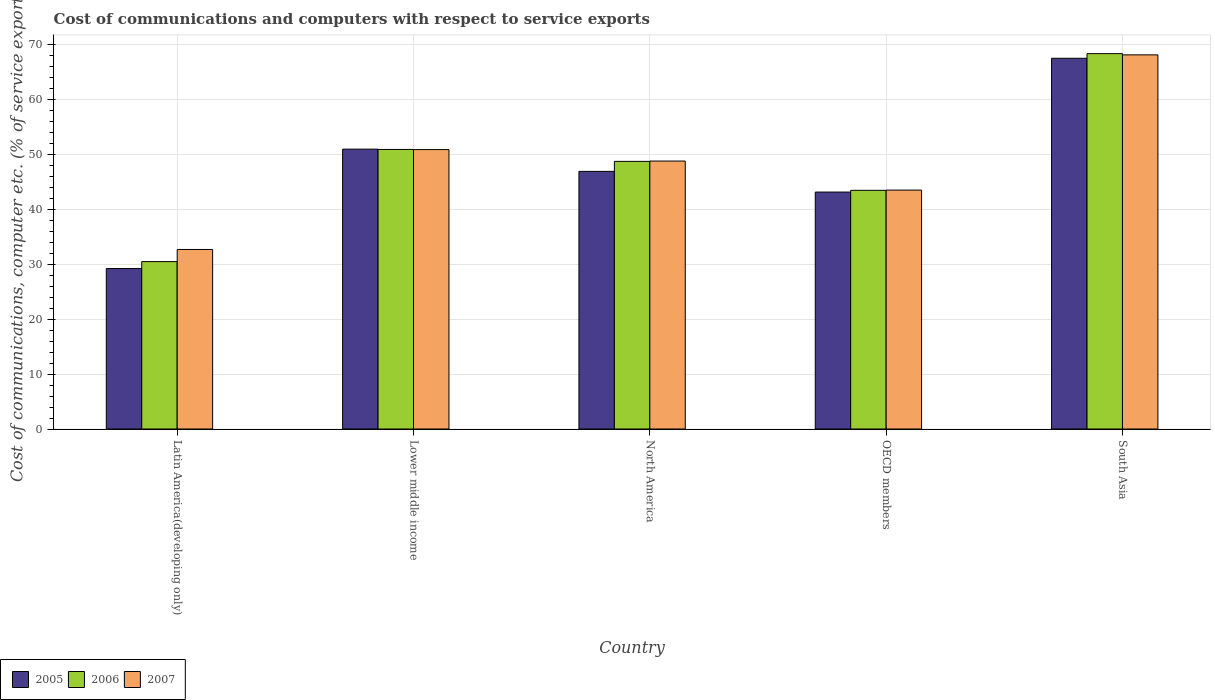How many different coloured bars are there?
Provide a short and direct response. 3. Are the number of bars per tick equal to the number of legend labels?
Provide a succinct answer. Yes. Are the number of bars on each tick of the X-axis equal?
Keep it short and to the point. Yes. How many bars are there on the 4th tick from the right?
Your answer should be compact. 3. What is the cost of communications and computers in 2007 in Latin America(developing only)?
Your answer should be very brief. 32.71. Across all countries, what is the maximum cost of communications and computers in 2007?
Offer a terse response. 68.16. Across all countries, what is the minimum cost of communications and computers in 2007?
Your response must be concise. 32.71. In which country was the cost of communications and computers in 2007 maximum?
Your response must be concise. South Asia. In which country was the cost of communications and computers in 2006 minimum?
Your answer should be compact. Latin America(developing only). What is the total cost of communications and computers in 2005 in the graph?
Give a very brief answer. 237.86. What is the difference between the cost of communications and computers in 2006 in North America and that in South Asia?
Provide a succinct answer. -19.63. What is the difference between the cost of communications and computers in 2005 in Latin America(developing only) and the cost of communications and computers in 2006 in Lower middle income?
Your response must be concise. -21.7. What is the average cost of communications and computers in 2005 per country?
Ensure brevity in your answer.  47.57. What is the difference between the cost of communications and computers of/in 2005 and cost of communications and computers of/in 2006 in OECD members?
Provide a succinct answer. -0.31. What is the ratio of the cost of communications and computers in 2005 in Latin America(developing only) to that in South Asia?
Provide a succinct answer. 0.43. What is the difference between the highest and the second highest cost of communications and computers in 2007?
Keep it short and to the point. -2.09. What is the difference between the highest and the lowest cost of communications and computers in 2005?
Provide a succinct answer. 38.31. Is the sum of the cost of communications and computers in 2007 in Latin America(developing only) and South Asia greater than the maximum cost of communications and computers in 2006 across all countries?
Your answer should be compact. Yes. What does the 3rd bar from the left in South Asia represents?
Your answer should be compact. 2007. Are all the bars in the graph horizontal?
Your answer should be compact. No. How many countries are there in the graph?
Provide a succinct answer. 5. Are the values on the major ticks of Y-axis written in scientific E-notation?
Offer a very short reply. No. What is the title of the graph?
Ensure brevity in your answer.  Cost of communications and computers with respect to service exports. What is the label or title of the Y-axis?
Your answer should be very brief. Cost of communications, computer etc. (% of service exports). What is the Cost of communications, computer etc. (% of service exports) in 2005 in Latin America(developing only)?
Your response must be concise. 29.23. What is the Cost of communications, computer etc. (% of service exports) in 2006 in Latin America(developing only)?
Keep it short and to the point. 30.5. What is the Cost of communications, computer etc. (% of service exports) of 2007 in Latin America(developing only)?
Provide a short and direct response. 32.71. What is the Cost of communications, computer etc. (% of service exports) of 2005 in Lower middle income?
Offer a terse response. 50.99. What is the Cost of communications, computer etc. (% of service exports) in 2006 in Lower middle income?
Provide a short and direct response. 50.93. What is the Cost of communications, computer etc. (% of service exports) in 2007 in Lower middle income?
Provide a succinct answer. 50.91. What is the Cost of communications, computer etc. (% of service exports) of 2005 in North America?
Your response must be concise. 46.93. What is the Cost of communications, computer etc. (% of service exports) of 2006 in North America?
Ensure brevity in your answer.  48.76. What is the Cost of communications, computer etc. (% of service exports) of 2007 in North America?
Ensure brevity in your answer.  48.82. What is the Cost of communications, computer etc. (% of service exports) in 2005 in OECD members?
Give a very brief answer. 43.17. What is the Cost of communications, computer etc. (% of service exports) of 2006 in OECD members?
Your response must be concise. 43.48. What is the Cost of communications, computer etc. (% of service exports) of 2007 in OECD members?
Offer a very short reply. 43.53. What is the Cost of communications, computer etc. (% of service exports) of 2005 in South Asia?
Your answer should be very brief. 67.54. What is the Cost of communications, computer etc. (% of service exports) of 2006 in South Asia?
Your answer should be compact. 68.39. What is the Cost of communications, computer etc. (% of service exports) in 2007 in South Asia?
Offer a terse response. 68.16. Across all countries, what is the maximum Cost of communications, computer etc. (% of service exports) of 2005?
Provide a succinct answer. 67.54. Across all countries, what is the maximum Cost of communications, computer etc. (% of service exports) of 2006?
Your response must be concise. 68.39. Across all countries, what is the maximum Cost of communications, computer etc. (% of service exports) in 2007?
Your answer should be very brief. 68.16. Across all countries, what is the minimum Cost of communications, computer etc. (% of service exports) in 2005?
Your answer should be compact. 29.23. Across all countries, what is the minimum Cost of communications, computer etc. (% of service exports) in 2006?
Offer a very short reply. 30.5. Across all countries, what is the minimum Cost of communications, computer etc. (% of service exports) of 2007?
Make the answer very short. 32.71. What is the total Cost of communications, computer etc. (% of service exports) in 2005 in the graph?
Provide a short and direct response. 237.86. What is the total Cost of communications, computer etc. (% of service exports) of 2006 in the graph?
Your response must be concise. 242.05. What is the total Cost of communications, computer etc. (% of service exports) in 2007 in the graph?
Keep it short and to the point. 244.12. What is the difference between the Cost of communications, computer etc. (% of service exports) in 2005 in Latin America(developing only) and that in Lower middle income?
Your answer should be very brief. -21.75. What is the difference between the Cost of communications, computer etc. (% of service exports) in 2006 in Latin America(developing only) and that in Lower middle income?
Give a very brief answer. -20.43. What is the difference between the Cost of communications, computer etc. (% of service exports) in 2007 in Latin America(developing only) and that in Lower middle income?
Keep it short and to the point. -18.2. What is the difference between the Cost of communications, computer etc. (% of service exports) of 2005 in Latin America(developing only) and that in North America?
Your answer should be compact. -17.7. What is the difference between the Cost of communications, computer etc. (% of service exports) in 2006 in Latin America(developing only) and that in North America?
Provide a short and direct response. -18.26. What is the difference between the Cost of communications, computer etc. (% of service exports) in 2007 in Latin America(developing only) and that in North America?
Make the answer very short. -16.11. What is the difference between the Cost of communications, computer etc. (% of service exports) in 2005 in Latin America(developing only) and that in OECD members?
Keep it short and to the point. -13.93. What is the difference between the Cost of communications, computer etc. (% of service exports) of 2006 in Latin America(developing only) and that in OECD members?
Your response must be concise. -12.98. What is the difference between the Cost of communications, computer etc. (% of service exports) in 2007 in Latin America(developing only) and that in OECD members?
Your answer should be very brief. -10.82. What is the difference between the Cost of communications, computer etc. (% of service exports) of 2005 in Latin America(developing only) and that in South Asia?
Ensure brevity in your answer.  -38.31. What is the difference between the Cost of communications, computer etc. (% of service exports) in 2006 in Latin America(developing only) and that in South Asia?
Offer a very short reply. -37.89. What is the difference between the Cost of communications, computer etc. (% of service exports) of 2007 in Latin America(developing only) and that in South Asia?
Keep it short and to the point. -35.45. What is the difference between the Cost of communications, computer etc. (% of service exports) of 2005 in Lower middle income and that in North America?
Your answer should be compact. 4.05. What is the difference between the Cost of communications, computer etc. (% of service exports) in 2006 in Lower middle income and that in North America?
Offer a very short reply. 2.17. What is the difference between the Cost of communications, computer etc. (% of service exports) of 2007 in Lower middle income and that in North America?
Offer a terse response. 2.09. What is the difference between the Cost of communications, computer etc. (% of service exports) of 2005 in Lower middle income and that in OECD members?
Provide a short and direct response. 7.82. What is the difference between the Cost of communications, computer etc. (% of service exports) of 2006 in Lower middle income and that in OECD members?
Make the answer very short. 7.45. What is the difference between the Cost of communications, computer etc. (% of service exports) of 2007 in Lower middle income and that in OECD members?
Offer a very short reply. 7.38. What is the difference between the Cost of communications, computer etc. (% of service exports) of 2005 in Lower middle income and that in South Asia?
Give a very brief answer. -16.55. What is the difference between the Cost of communications, computer etc. (% of service exports) of 2006 in Lower middle income and that in South Asia?
Offer a terse response. -17.45. What is the difference between the Cost of communications, computer etc. (% of service exports) in 2007 in Lower middle income and that in South Asia?
Make the answer very short. -17.25. What is the difference between the Cost of communications, computer etc. (% of service exports) in 2005 in North America and that in OECD members?
Give a very brief answer. 3.77. What is the difference between the Cost of communications, computer etc. (% of service exports) of 2006 in North America and that in OECD members?
Your response must be concise. 5.28. What is the difference between the Cost of communications, computer etc. (% of service exports) in 2007 in North America and that in OECD members?
Provide a succinct answer. 5.29. What is the difference between the Cost of communications, computer etc. (% of service exports) of 2005 in North America and that in South Asia?
Offer a terse response. -20.61. What is the difference between the Cost of communications, computer etc. (% of service exports) in 2006 in North America and that in South Asia?
Ensure brevity in your answer.  -19.63. What is the difference between the Cost of communications, computer etc. (% of service exports) in 2007 in North America and that in South Asia?
Keep it short and to the point. -19.34. What is the difference between the Cost of communications, computer etc. (% of service exports) of 2005 in OECD members and that in South Asia?
Provide a succinct answer. -24.37. What is the difference between the Cost of communications, computer etc. (% of service exports) of 2006 in OECD members and that in South Asia?
Provide a short and direct response. -24.9. What is the difference between the Cost of communications, computer etc. (% of service exports) in 2007 in OECD members and that in South Asia?
Make the answer very short. -24.63. What is the difference between the Cost of communications, computer etc. (% of service exports) of 2005 in Latin America(developing only) and the Cost of communications, computer etc. (% of service exports) of 2006 in Lower middle income?
Ensure brevity in your answer.  -21.7. What is the difference between the Cost of communications, computer etc. (% of service exports) of 2005 in Latin America(developing only) and the Cost of communications, computer etc. (% of service exports) of 2007 in Lower middle income?
Provide a short and direct response. -21.67. What is the difference between the Cost of communications, computer etc. (% of service exports) of 2006 in Latin America(developing only) and the Cost of communications, computer etc. (% of service exports) of 2007 in Lower middle income?
Make the answer very short. -20.41. What is the difference between the Cost of communications, computer etc. (% of service exports) in 2005 in Latin America(developing only) and the Cost of communications, computer etc. (% of service exports) in 2006 in North America?
Offer a terse response. -19.53. What is the difference between the Cost of communications, computer etc. (% of service exports) of 2005 in Latin America(developing only) and the Cost of communications, computer etc. (% of service exports) of 2007 in North America?
Offer a terse response. -19.59. What is the difference between the Cost of communications, computer etc. (% of service exports) of 2006 in Latin America(developing only) and the Cost of communications, computer etc. (% of service exports) of 2007 in North America?
Your response must be concise. -18.32. What is the difference between the Cost of communications, computer etc. (% of service exports) of 2005 in Latin America(developing only) and the Cost of communications, computer etc. (% of service exports) of 2006 in OECD members?
Offer a terse response. -14.25. What is the difference between the Cost of communications, computer etc. (% of service exports) in 2005 in Latin America(developing only) and the Cost of communications, computer etc. (% of service exports) in 2007 in OECD members?
Offer a very short reply. -14.3. What is the difference between the Cost of communications, computer etc. (% of service exports) in 2006 in Latin America(developing only) and the Cost of communications, computer etc. (% of service exports) in 2007 in OECD members?
Your answer should be very brief. -13.03. What is the difference between the Cost of communications, computer etc. (% of service exports) of 2005 in Latin America(developing only) and the Cost of communications, computer etc. (% of service exports) of 2006 in South Asia?
Offer a very short reply. -39.15. What is the difference between the Cost of communications, computer etc. (% of service exports) of 2005 in Latin America(developing only) and the Cost of communications, computer etc. (% of service exports) of 2007 in South Asia?
Your answer should be compact. -38.93. What is the difference between the Cost of communications, computer etc. (% of service exports) of 2006 in Latin America(developing only) and the Cost of communications, computer etc. (% of service exports) of 2007 in South Asia?
Keep it short and to the point. -37.66. What is the difference between the Cost of communications, computer etc. (% of service exports) of 2005 in Lower middle income and the Cost of communications, computer etc. (% of service exports) of 2006 in North America?
Your answer should be compact. 2.23. What is the difference between the Cost of communications, computer etc. (% of service exports) in 2005 in Lower middle income and the Cost of communications, computer etc. (% of service exports) in 2007 in North America?
Your response must be concise. 2.17. What is the difference between the Cost of communications, computer etc. (% of service exports) in 2006 in Lower middle income and the Cost of communications, computer etc. (% of service exports) in 2007 in North America?
Offer a terse response. 2.11. What is the difference between the Cost of communications, computer etc. (% of service exports) in 2005 in Lower middle income and the Cost of communications, computer etc. (% of service exports) in 2006 in OECD members?
Keep it short and to the point. 7.5. What is the difference between the Cost of communications, computer etc. (% of service exports) in 2005 in Lower middle income and the Cost of communications, computer etc. (% of service exports) in 2007 in OECD members?
Your answer should be very brief. 7.46. What is the difference between the Cost of communications, computer etc. (% of service exports) of 2006 in Lower middle income and the Cost of communications, computer etc. (% of service exports) of 2007 in OECD members?
Your answer should be compact. 7.4. What is the difference between the Cost of communications, computer etc. (% of service exports) in 2005 in Lower middle income and the Cost of communications, computer etc. (% of service exports) in 2006 in South Asia?
Keep it short and to the point. -17.4. What is the difference between the Cost of communications, computer etc. (% of service exports) in 2005 in Lower middle income and the Cost of communications, computer etc. (% of service exports) in 2007 in South Asia?
Provide a short and direct response. -17.18. What is the difference between the Cost of communications, computer etc. (% of service exports) of 2006 in Lower middle income and the Cost of communications, computer etc. (% of service exports) of 2007 in South Asia?
Ensure brevity in your answer.  -17.23. What is the difference between the Cost of communications, computer etc. (% of service exports) of 2005 in North America and the Cost of communications, computer etc. (% of service exports) of 2006 in OECD members?
Offer a very short reply. 3.45. What is the difference between the Cost of communications, computer etc. (% of service exports) in 2005 in North America and the Cost of communications, computer etc. (% of service exports) in 2007 in OECD members?
Make the answer very short. 3.41. What is the difference between the Cost of communications, computer etc. (% of service exports) in 2006 in North America and the Cost of communications, computer etc. (% of service exports) in 2007 in OECD members?
Provide a succinct answer. 5.23. What is the difference between the Cost of communications, computer etc. (% of service exports) in 2005 in North America and the Cost of communications, computer etc. (% of service exports) in 2006 in South Asia?
Offer a very short reply. -21.45. What is the difference between the Cost of communications, computer etc. (% of service exports) of 2005 in North America and the Cost of communications, computer etc. (% of service exports) of 2007 in South Asia?
Make the answer very short. -21.23. What is the difference between the Cost of communications, computer etc. (% of service exports) of 2006 in North America and the Cost of communications, computer etc. (% of service exports) of 2007 in South Asia?
Make the answer very short. -19.4. What is the difference between the Cost of communications, computer etc. (% of service exports) of 2005 in OECD members and the Cost of communications, computer etc. (% of service exports) of 2006 in South Asia?
Offer a terse response. -25.22. What is the difference between the Cost of communications, computer etc. (% of service exports) of 2005 in OECD members and the Cost of communications, computer etc. (% of service exports) of 2007 in South Asia?
Your response must be concise. -24.99. What is the difference between the Cost of communications, computer etc. (% of service exports) in 2006 in OECD members and the Cost of communications, computer etc. (% of service exports) in 2007 in South Asia?
Offer a terse response. -24.68. What is the average Cost of communications, computer etc. (% of service exports) of 2005 per country?
Provide a short and direct response. 47.57. What is the average Cost of communications, computer etc. (% of service exports) of 2006 per country?
Offer a very short reply. 48.41. What is the average Cost of communications, computer etc. (% of service exports) of 2007 per country?
Give a very brief answer. 48.82. What is the difference between the Cost of communications, computer etc. (% of service exports) in 2005 and Cost of communications, computer etc. (% of service exports) in 2006 in Latin America(developing only)?
Ensure brevity in your answer.  -1.26. What is the difference between the Cost of communications, computer etc. (% of service exports) of 2005 and Cost of communications, computer etc. (% of service exports) of 2007 in Latin America(developing only)?
Your response must be concise. -3.48. What is the difference between the Cost of communications, computer etc. (% of service exports) of 2006 and Cost of communications, computer etc. (% of service exports) of 2007 in Latin America(developing only)?
Make the answer very short. -2.21. What is the difference between the Cost of communications, computer etc. (% of service exports) of 2005 and Cost of communications, computer etc. (% of service exports) of 2006 in Lower middle income?
Offer a very short reply. 0.06. What is the difference between the Cost of communications, computer etc. (% of service exports) in 2005 and Cost of communications, computer etc. (% of service exports) in 2007 in Lower middle income?
Your answer should be compact. 0.08. What is the difference between the Cost of communications, computer etc. (% of service exports) in 2006 and Cost of communications, computer etc. (% of service exports) in 2007 in Lower middle income?
Your answer should be compact. 0.02. What is the difference between the Cost of communications, computer etc. (% of service exports) of 2005 and Cost of communications, computer etc. (% of service exports) of 2006 in North America?
Keep it short and to the point. -1.82. What is the difference between the Cost of communications, computer etc. (% of service exports) of 2005 and Cost of communications, computer etc. (% of service exports) of 2007 in North America?
Provide a short and direct response. -1.88. What is the difference between the Cost of communications, computer etc. (% of service exports) of 2006 and Cost of communications, computer etc. (% of service exports) of 2007 in North America?
Your answer should be very brief. -0.06. What is the difference between the Cost of communications, computer etc. (% of service exports) in 2005 and Cost of communications, computer etc. (% of service exports) in 2006 in OECD members?
Make the answer very short. -0.32. What is the difference between the Cost of communications, computer etc. (% of service exports) of 2005 and Cost of communications, computer etc. (% of service exports) of 2007 in OECD members?
Offer a terse response. -0.36. What is the difference between the Cost of communications, computer etc. (% of service exports) in 2006 and Cost of communications, computer etc. (% of service exports) in 2007 in OECD members?
Ensure brevity in your answer.  -0.05. What is the difference between the Cost of communications, computer etc. (% of service exports) in 2005 and Cost of communications, computer etc. (% of service exports) in 2006 in South Asia?
Your answer should be very brief. -0.84. What is the difference between the Cost of communications, computer etc. (% of service exports) of 2005 and Cost of communications, computer etc. (% of service exports) of 2007 in South Asia?
Provide a short and direct response. -0.62. What is the difference between the Cost of communications, computer etc. (% of service exports) of 2006 and Cost of communications, computer etc. (% of service exports) of 2007 in South Asia?
Provide a short and direct response. 0.22. What is the ratio of the Cost of communications, computer etc. (% of service exports) of 2005 in Latin America(developing only) to that in Lower middle income?
Ensure brevity in your answer.  0.57. What is the ratio of the Cost of communications, computer etc. (% of service exports) of 2006 in Latin America(developing only) to that in Lower middle income?
Offer a very short reply. 0.6. What is the ratio of the Cost of communications, computer etc. (% of service exports) of 2007 in Latin America(developing only) to that in Lower middle income?
Offer a terse response. 0.64. What is the ratio of the Cost of communications, computer etc. (% of service exports) of 2005 in Latin America(developing only) to that in North America?
Offer a very short reply. 0.62. What is the ratio of the Cost of communications, computer etc. (% of service exports) of 2006 in Latin America(developing only) to that in North America?
Offer a terse response. 0.63. What is the ratio of the Cost of communications, computer etc. (% of service exports) in 2007 in Latin America(developing only) to that in North America?
Provide a short and direct response. 0.67. What is the ratio of the Cost of communications, computer etc. (% of service exports) of 2005 in Latin America(developing only) to that in OECD members?
Provide a succinct answer. 0.68. What is the ratio of the Cost of communications, computer etc. (% of service exports) in 2006 in Latin America(developing only) to that in OECD members?
Give a very brief answer. 0.7. What is the ratio of the Cost of communications, computer etc. (% of service exports) of 2007 in Latin America(developing only) to that in OECD members?
Ensure brevity in your answer.  0.75. What is the ratio of the Cost of communications, computer etc. (% of service exports) of 2005 in Latin America(developing only) to that in South Asia?
Your answer should be very brief. 0.43. What is the ratio of the Cost of communications, computer etc. (% of service exports) in 2006 in Latin America(developing only) to that in South Asia?
Give a very brief answer. 0.45. What is the ratio of the Cost of communications, computer etc. (% of service exports) in 2007 in Latin America(developing only) to that in South Asia?
Provide a succinct answer. 0.48. What is the ratio of the Cost of communications, computer etc. (% of service exports) in 2005 in Lower middle income to that in North America?
Provide a short and direct response. 1.09. What is the ratio of the Cost of communications, computer etc. (% of service exports) of 2006 in Lower middle income to that in North America?
Provide a succinct answer. 1.04. What is the ratio of the Cost of communications, computer etc. (% of service exports) in 2007 in Lower middle income to that in North America?
Ensure brevity in your answer.  1.04. What is the ratio of the Cost of communications, computer etc. (% of service exports) in 2005 in Lower middle income to that in OECD members?
Provide a short and direct response. 1.18. What is the ratio of the Cost of communications, computer etc. (% of service exports) in 2006 in Lower middle income to that in OECD members?
Ensure brevity in your answer.  1.17. What is the ratio of the Cost of communications, computer etc. (% of service exports) of 2007 in Lower middle income to that in OECD members?
Make the answer very short. 1.17. What is the ratio of the Cost of communications, computer etc. (% of service exports) in 2005 in Lower middle income to that in South Asia?
Your answer should be compact. 0.75. What is the ratio of the Cost of communications, computer etc. (% of service exports) of 2006 in Lower middle income to that in South Asia?
Give a very brief answer. 0.74. What is the ratio of the Cost of communications, computer etc. (% of service exports) of 2007 in Lower middle income to that in South Asia?
Make the answer very short. 0.75. What is the ratio of the Cost of communications, computer etc. (% of service exports) of 2005 in North America to that in OECD members?
Offer a very short reply. 1.09. What is the ratio of the Cost of communications, computer etc. (% of service exports) in 2006 in North America to that in OECD members?
Give a very brief answer. 1.12. What is the ratio of the Cost of communications, computer etc. (% of service exports) in 2007 in North America to that in OECD members?
Keep it short and to the point. 1.12. What is the ratio of the Cost of communications, computer etc. (% of service exports) of 2005 in North America to that in South Asia?
Ensure brevity in your answer.  0.69. What is the ratio of the Cost of communications, computer etc. (% of service exports) in 2006 in North America to that in South Asia?
Give a very brief answer. 0.71. What is the ratio of the Cost of communications, computer etc. (% of service exports) in 2007 in North America to that in South Asia?
Provide a short and direct response. 0.72. What is the ratio of the Cost of communications, computer etc. (% of service exports) of 2005 in OECD members to that in South Asia?
Give a very brief answer. 0.64. What is the ratio of the Cost of communications, computer etc. (% of service exports) of 2006 in OECD members to that in South Asia?
Your response must be concise. 0.64. What is the ratio of the Cost of communications, computer etc. (% of service exports) of 2007 in OECD members to that in South Asia?
Your response must be concise. 0.64. What is the difference between the highest and the second highest Cost of communications, computer etc. (% of service exports) of 2005?
Your response must be concise. 16.55. What is the difference between the highest and the second highest Cost of communications, computer etc. (% of service exports) in 2006?
Provide a short and direct response. 17.45. What is the difference between the highest and the second highest Cost of communications, computer etc. (% of service exports) in 2007?
Offer a terse response. 17.25. What is the difference between the highest and the lowest Cost of communications, computer etc. (% of service exports) in 2005?
Keep it short and to the point. 38.31. What is the difference between the highest and the lowest Cost of communications, computer etc. (% of service exports) in 2006?
Give a very brief answer. 37.89. What is the difference between the highest and the lowest Cost of communications, computer etc. (% of service exports) in 2007?
Ensure brevity in your answer.  35.45. 